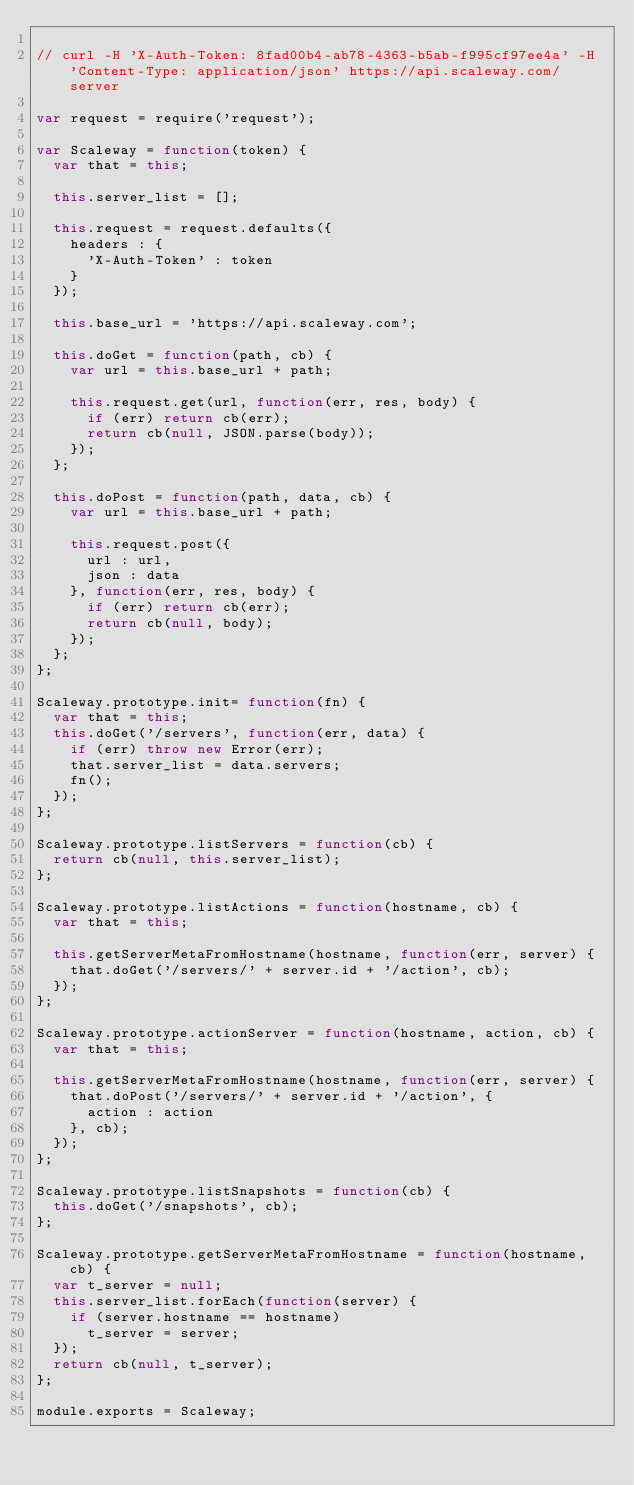<code> <loc_0><loc_0><loc_500><loc_500><_JavaScript_>
// curl -H 'X-Auth-Token: 8fad00b4-ab78-4363-b5ab-f995cf97ee4a' -H 'Content-Type: application/json' https://api.scaleway.com/server

var request = require('request');

var Scaleway = function(token) {
  var that = this;

  this.server_list = [];

  this.request = request.defaults({
    headers : {
      'X-Auth-Token' : token
    }
  });

  this.base_url = 'https://api.scaleway.com';

  this.doGet = function(path, cb) {
    var url = this.base_url + path;

    this.request.get(url, function(err, res, body) {
      if (err) return cb(err);
      return cb(null, JSON.parse(body));
    });
  };

  this.doPost = function(path, data, cb) {
    var url = this.base_url + path;

    this.request.post({
      url : url,
      json : data
    }, function(err, res, body) {
      if (err) return cb(err);
      return cb(null, body);
    });
  };
};

Scaleway.prototype.init= function(fn) {
  var that = this;
  this.doGet('/servers', function(err, data) {
    if (err) throw new Error(err);
    that.server_list = data.servers;
    fn();
  });
};

Scaleway.prototype.listServers = function(cb) {
  return cb(null, this.server_list);
};

Scaleway.prototype.listActions = function(hostname, cb) {
  var that = this;

  this.getServerMetaFromHostname(hostname, function(err, server) {
    that.doGet('/servers/' + server.id + '/action', cb);
  });
};

Scaleway.prototype.actionServer = function(hostname, action, cb) {
  var that = this;

  this.getServerMetaFromHostname(hostname, function(err, server) {
    that.doPost('/servers/' + server.id + '/action', {
      action : action
    }, cb);
  });
};

Scaleway.prototype.listSnapshots = function(cb) {
  this.doGet('/snapshots', cb);
};

Scaleway.prototype.getServerMetaFromHostname = function(hostname, cb) {
  var t_server = null;
  this.server_list.forEach(function(server) {
    if (server.hostname == hostname)
      t_server = server;
  });
  return cb(null, t_server);
};

module.exports = Scaleway;
</code> 